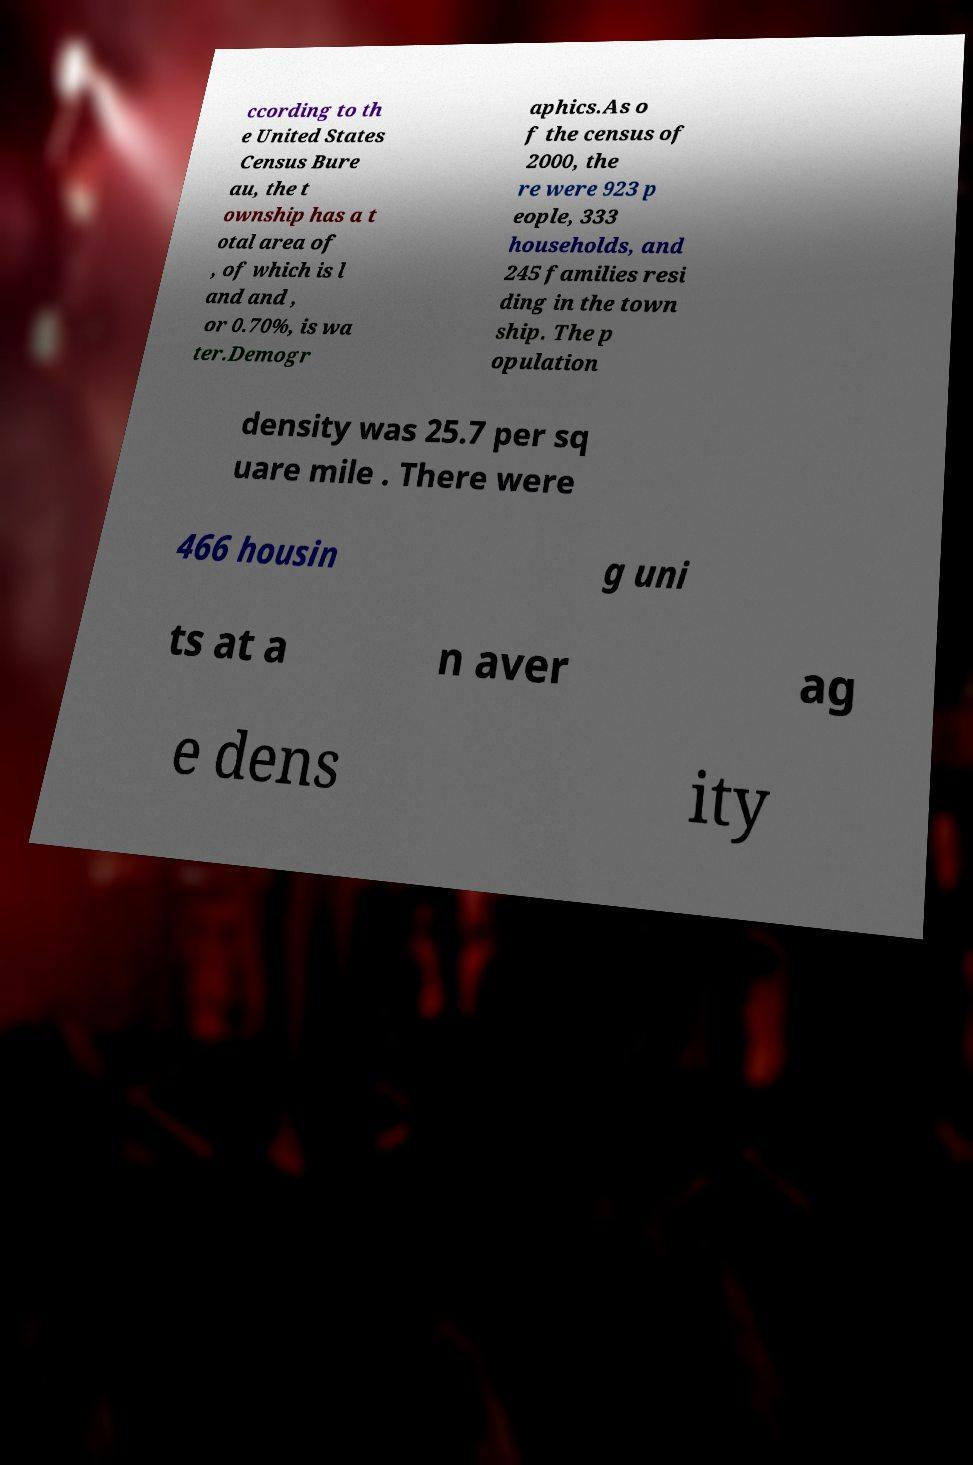Could you assist in decoding the text presented in this image and type it out clearly? ccording to th e United States Census Bure au, the t ownship has a t otal area of , of which is l and and , or 0.70%, is wa ter.Demogr aphics.As o f the census of 2000, the re were 923 p eople, 333 households, and 245 families resi ding in the town ship. The p opulation density was 25.7 per sq uare mile . There were 466 housin g uni ts at a n aver ag e dens ity 